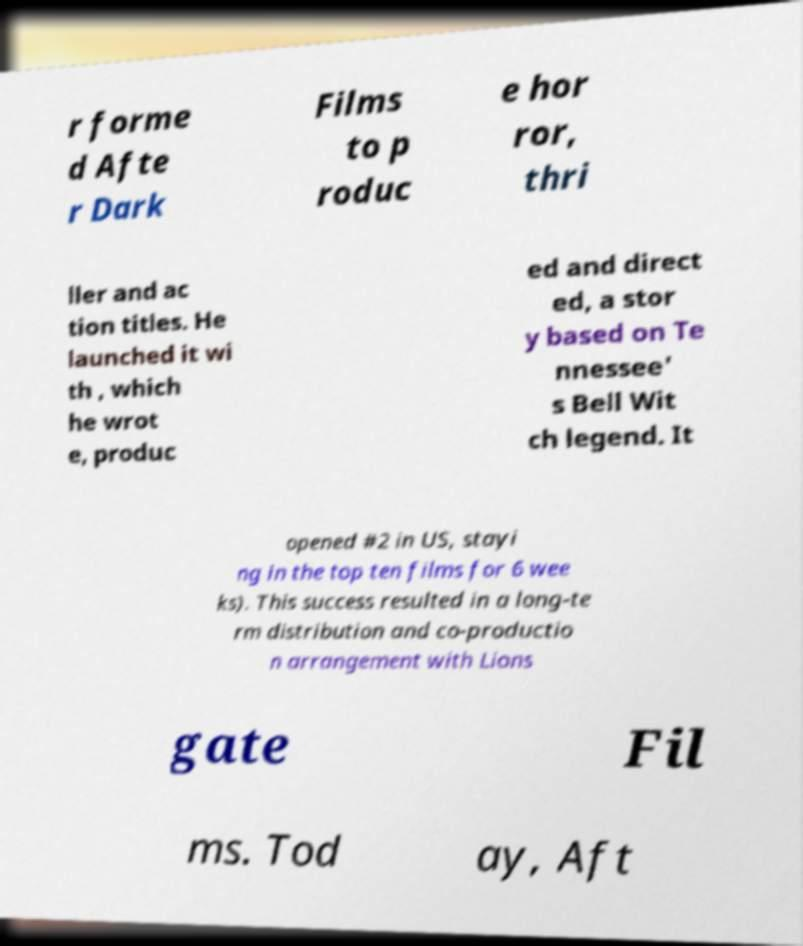Can you accurately transcribe the text from the provided image for me? r forme d Afte r Dark Films to p roduc e hor ror, thri ller and ac tion titles. He launched it wi th , which he wrot e, produc ed and direct ed, a stor y based on Te nnessee' s Bell Wit ch legend. It opened #2 in US, stayi ng in the top ten films for 6 wee ks). This success resulted in a long-te rm distribution and co-productio n arrangement with Lions gate Fil ms. Tod ay, Aft 